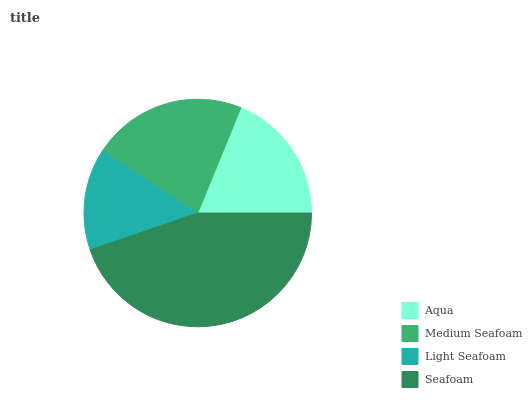Is Light Seafoam the minimum?
Answer yes or no. Yes. Is Seafoam the maximum?
Answer yes or no. Yes. Is Medium Seafoam the minimum?
Answer yes or no. No. Is Medium Seafoam the maximum?
Answer yes or no. No. Is Medium Seafoam greater than Aqua?
Answer yes or no. Yes. Is Aqua less than Medium Seafoam?
Answer yes or no. Yes. Is Aqua greater than Medium Seafoam?
Answer yes or no. No. Is Medium Seafoam less than Aqua?
Answer yes or no. No. Is Medium Seafoam the high median?
Answer yes or no. Yes. Is Aqua the low median?
Answer yes or no. Yes. Is Light Seafoam the high median?
Answer yes or no. No. Is Medium Seafoam the low median?
Answer yes or no. No. 